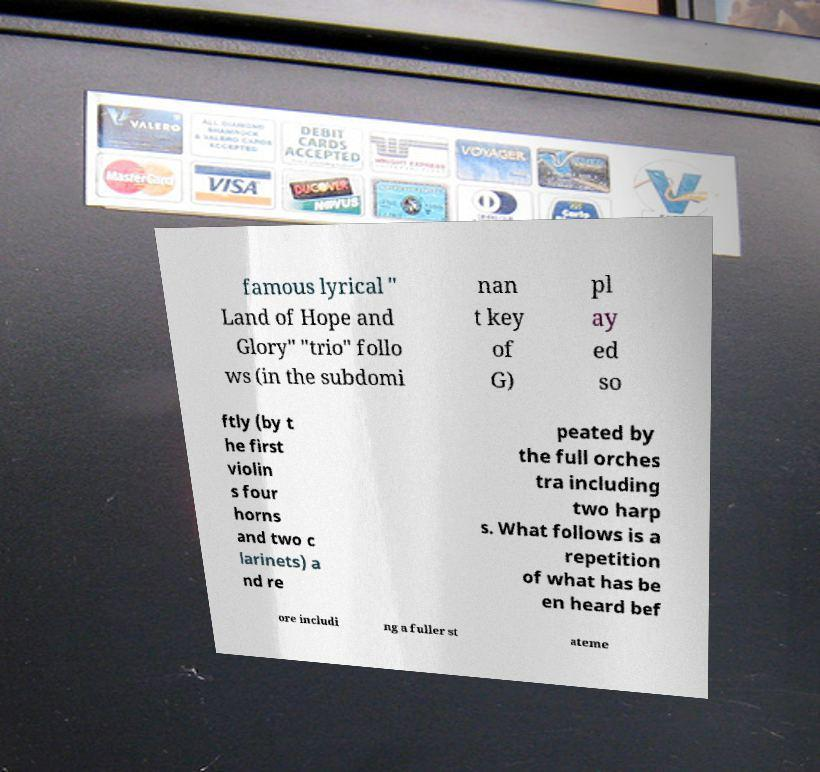Can you read and provide the text displayed in the image?This photo seems to have some interesting text. Can you extract and type it out for me? famous lyrical " Land of Hope and Glory" "trio" follo ws (in the subdomi nan t key of G) pl ay ed so ftly (by t he first violin s four horns and two c larinets) a nd re peated by the full orches tra including two harp s. What follows is a repetition of what has be en heard bef ore includi ng a fuller st ateme 